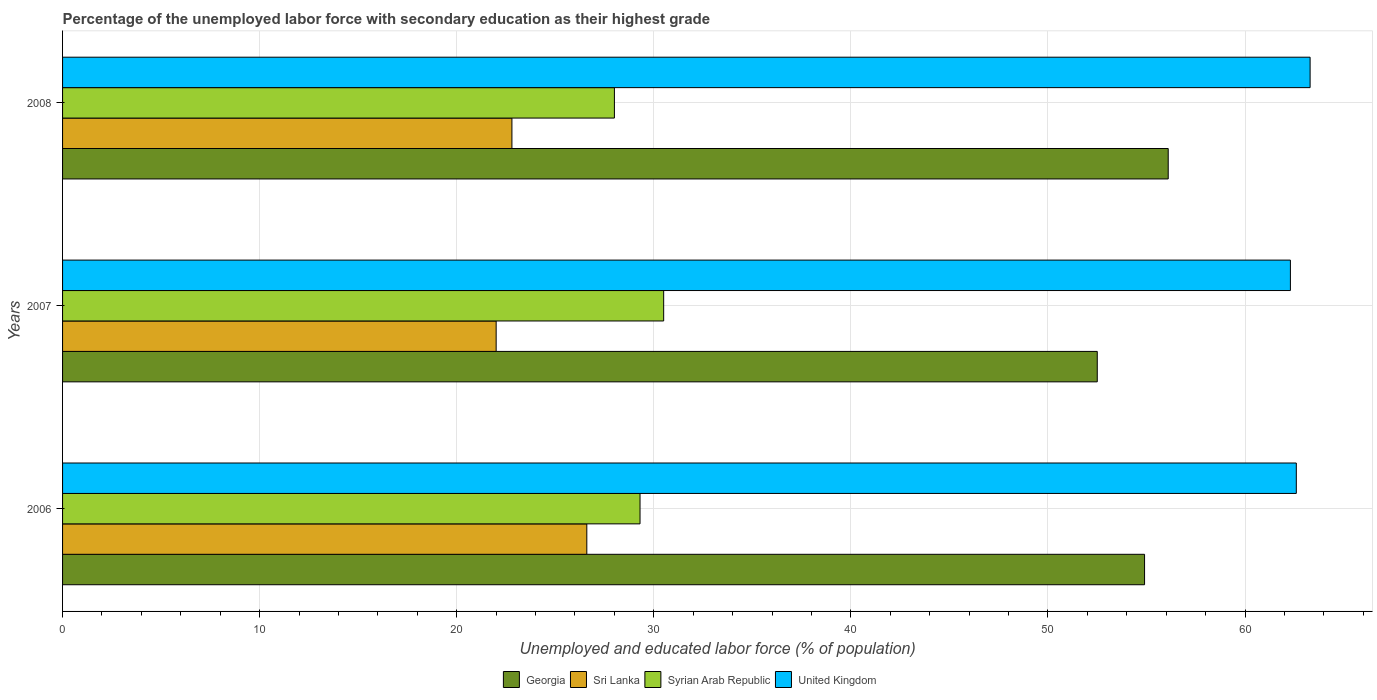How many different coloured bars are there?
Your response must be concise. 4. How many groups of bars are there?
Your response must be concise. 3. How many bars are there on the 1st tick from the bottom?
Your response must be concise. 4. What is the label of the 2nd group of bars from the top?
Your response must be concise. 2007. What is the percentage of the unemployed labor force with secondary education in Georgia in 2006?
Your response must be concise. 54.9. Across all years, what is the maximum percentage of the unemployed labor force with secondary education in Syrian Arab Republic?
Provide a succinct answer. 30.5. Across all years, what is the minimum percentage of the unemployed labor force with secondary education in United Kingdom?
Provide a succinct answer. 62.3. In which year was the percentage of the unemployed labor force with secondary education in Sri Lanka minimum?
Provide a short and direct response. 2007. What is the total percentage of the unemployed labor force with secondary education in United Kingdom in the graph?
Keep it short and to the point. 188.2. What is the difference between the percentage of the unemployed labor force with secondary education in United Kingdom in 2006 and that in 2008?
Your response must be concise. -0.7. What is the difference between the percentage of the unemployed labor force with secondary education in United Kingdom in 2006 and the percentage of the unemployed labor force with secondary education in Georgia in 2007?
Ensure brevity in your answer.  10.1. What is the average percentage of the unemployed labor force with secondary education in Georgia per year?
Your response must be concise. 54.5. In the year 2007, what is the difference between the percentage of the unemployed labor force with secondary education in Sri Lanka and percentage of the unemployed labor force with secondary education in Syrian Arab Republic?
Ensure brevity in your answer.  -8.5. In how many years, is the percentage of the unemployed labor force with secondary education in Syrian Arab Republic greater than 32 %?
Keep it short and to the point. 0. What is the ratio of the percentage of the unemployed labor force with secondary education in Georgia in 2006 to that in 2008?
Offer a very short reply. 0.98. Is the difference between the percentage of the unemployed labor force with secondary education in Sri Lanka in 2007 and 2008 greater than the difference between the percentage of the unemployed labor force with secondary education in Syrian Arab Republic in 2007 and 2008?
Your answer should be compact. No. What is the difference between the highest and the second highest percentage of the unemployed labor force with secondary education in United Kingdom?
Provide a succinct answer. 0.7. In how many years, is the percentage of the unemployed labor force with secondary education in Syrian Arab Republic greater than the average percentage of the unemployed labor force with secondary education in Syrian Arab Republic taken over all years?
Ensure brevity in your answer.  2. Is the sum of the percentage of the unemployed labor force with secondary education in Syrian Arab Republic in 2006 and 2007 greater than the maximum percentage of the unemployed labor force with secondary education in Sri Lanka across all years?
Your response must be concise. Yes. What does the 2nd bar from the top in 2006 represents?
Make the answer very short. Syrian Arab Republic. What does the 2nd bar from the bottom in 2006 represents?
Give a very brief answer. Sri Lanka. Is it the case that in every year, the sum of the percentage of the unemployed labor force with secondary education in United Kingdom and percentage of the unemployed labor force with secondary education in Sri Lanka is greater than the percentage of the unemployed labor force with secondary education in Georgia?
Make the answer very short. Yes. Are all the bars in the graph horizontal?
Ensure brevity in your answer.  Yes. What is the difference between two consecutive major ticks on the X-axis?
Keep it short and to the point. 10. Are the values on the major ticks of X-axis written in scientific E-notation?
Make the answer very short. No. Does the graph contain any zero values?
Your answer should be compact. No. Does the graph contain grids?
Your response must be concise. Yes. Where does the legend appear in the graph?
Provide a succinct answer. Bottom center. How are the legend labels stacked?
Your response must be concise. Horizontal. What is the title of the graph?
Keep it short and to the point. Percentage of the unemployed labor force with secondary education as their highest grade. Does "Guam" appear as one of the legend labels in the graph?
Your answer should be compact. No. What is the label or title of the X-axis?
Offer a very short reply. Unemployed and educated labor force (% of population). What is the Unemployed and educated labor force (% of population) in Georgia in 2006?
Make the answer very short. 54.9. What is the Unemployed and educated labor force (% of population) of Sri Lanka in 2006?
Ensure brevity in your answer.  26.6. What is the Unemployed and educated labor force (% of population) in Syrian Arab Republic in 2006?
Give a very brief answer. 29.3. What is the Unemployed and educated labor force (% of population) of United Kingdom in 2006?
Offer a terse response. 62.6. What is the Unemployed and educated labor force (% of population) in Georgia in 2007?
Your answer should be very brief. 52.5. What is the Unemployed and educated labor force (% of population) of Sri Lanka in 2007?
Provide a succinct answer. 22. What is the Unemployed and educated labor force (% of population) in Syrian Arab Republic in 2007?
Make the answer very short. 30.5. What is the Unemployed and educated labor force (% of population) in United Kingdom in 2007?
Your answer should be very brief. 62.3. What is the Unemployed and educated labor force (% of population) of Georgia in 2008?
Provide a succinct answer. 56.1. What is the Unemployed and educated labor force (% of population) of Sri Lanka in 2008?
Give a very brief answer. 22.8. What is the Unemployed and educated labor force (% of population) in United Kingdom in 2008?
Your answer should be very brief. 63.3. Across all years, what is the maximum Unemployed and educated labor force (% of population) of Georgia?
Keep it short and to the point. 56.1. Across all years, what is the maximum Unemployed and educated labor force (% of population) of Sri Lanka?
Ensure brevity in your answer.  26.6. Across all years, what is the maximum Unemployed and educated labor force (% of population) in Syrian Arab Republic?
Keep it short and to the point. 30.5. Across all years, what is the maximum Unemployed and educated labor force (% of population) in United Kingdom?
Your answer should be very brief. 63.3. Across all years, what is the minimum Unemployed and educated labor force (% of population) in Georgia?
Provide a short and direct response. 52.5. Across all years, what is the minimum Unemployed and educated labor force (% of population) of Sri Lanka?
Your answer should be very brief. 22. Across all years, what is the minimum Unemployed and educated labor force (% of population) in Syrian Arab Republic?
Your answer should be very brief. 28. Across all years, what is the minimum Unemployed and educated labor force (% of population) in United Kingdom?
Ensure brevity in your answer.  62.3. What is the total Unemployed and educated labor force (% of population) in Georgia in the graph?
Keep it short and to the point. 163.5. What is the total Unemployed and educated labor force (% of population) in Sri Lanka in the graph?
Keep it short and to the point. 71.4. What is the total Unemployed and educated labor force (% of population) of Syrian Arab Republic in the graph?
Your answer should be compact. 87.8. What is the total Unemployed and educated labor force (% of population) of United Kingdom in the graph?
Your response must be concise. 188.2. What is the difference between the Unemployed and educated labor force (% of population) of Georgia in 2006 and that in 2007?
Provide a succinct answer. 2.4. What is the difference between the Unemployed and educated labor force (% of population) of Sri Lanka in 2006 and that in 2007?
Ensure brevity in your answer.  4.6. What is the difference between the Unemployed and educated labor force (% of population) of Syrian Arab Republic in 2006 and that in 2007?
Make the answer very short. -1.2. What is the difference between the Unemployed and educated labor force (% of population) of United Kingdom in 2006 and that in 2007?
Keep it short and to the point. 0.3. What is the difference between the Unemployed and educated labor force (% of population) of Georgia in 2006 and that in 2008?
Offer a terse response. -1.2. What is the difference between the Unemployed and educated labor force (% of population) in Syrian Arab Republic in 2006 and that in 2008?
Your answer should be compact. 1.3. What is the difference between the Unemployed and educated labor force (% of population) of Georgia in 2007 and that in 2008?
Your answer should be compact. -3.6. What is the difference between the Unemployed and educated labor force (% of population) in United Kingdom in 2007 and that in 2008?
Provide a short and direct response. -1. What is the difference between the Unemployed and educated labor force (% of population) of Georgia in 2006 and the Unemployed and educated labor force (% of population) of Sri Lanka in 2007?
Ensure brevity in your answer.  32.9. What is the difference between the Unemployed and educated labor force (% of population) of Georgia in 2006 and the Unemployed and educated labor force (% of population) of Syrian Arab Republic in 2007?
Keep it short and to the point. 24.4. What is the difference between the Unemployed and educated labor force (% of population) of Sri Lanka in 2006 and the Unemployed and educated labor force (% of population) of United Kingdom in 2007?
Offer a terse response. -35.7. What is the difference between the Unemployed and educated labor force (% of population) in Syrian Arab Republic in 2006 and the Unemployed and educated labor force (% of population) in United Kingdom in 2007?
Provide a succinct answer. -33. What is the difference between the Unemployed and educated labor force (% of population) of Georgia in 2006 and the Unemployed and educated labor force (% of population) of Sri Lanka in 2008?
Offer a very short reply. 32.1. What is the difference between the Unemployed and educated labor force (% of population) of Georgia in 2006 and the Unemployed and educated labor force (% of population) of Syrian Arab Republic in 2008?
Your answer should be compact. 26.9. What is the difference between the Unemployed and educated labor force (% of population) in Sri Lanka in 2006 and the Unemployed and educated labor force (% of population) in United Kingdom in 2008?
Your answer should be compact. -36.7. What is the difference between the Unemployed and educated labor force (% of population) in Syrian Arab Republic in 2006 and the Unemployed and educated labor force (% of population) in United Kingdom in 2008?
Offer a very short reply. -34. What is the difference between the Unemployed and educated labor force (% of population) in Georgia in 2007 and the Unemployed and educated labor force (% of population) in Sri Lanka in 2008?
Your response must be concise. 29.7. What is the difference between the Unemployed and educated labor force (% of population) of Georgia in 2007 and the Unemployed and educated labor force (% of population) of United Kingdom in 2008?
Make the answer very short. -10.8. What is the difference between the Unemployed and educated labor force (% of population) in Sri Lanka in 2007 and the Unemployed and educated labor force (% of population) in United Kingdom in 2008?
Your answer should be very brief. -41.3. What is the difference between the Unemployed and educated labor force (% of population) in Syrian Arab Republic in 2007 and the Unemployed and educated labor force (% of population) in United Kingdom in 2008?
Make the answer very short. -32.8. What is the average Unemployed and educated labor force (% of population) in Georgia per year?
Ensure brevity in your answer.  54.5. What is the average Unemployed and educated labor force (% of population) of Sri Lanka per year?
Make the answer very short. 23.8. What is the average Unemployed and educated labor force (% of population) of Syrian Arab Republic per year?
Keep it short and to the point. 29.27. What is the average Unemployed and educated labor force (% of population) of United Kingdom per year?
Ensure brevity in your answer.  62.73. In the year 2006, what is the difference between the Unemployed and educated labor force (% of population) of Georgia and Unemployed and educated labor force (% of population) of Sri Lanka?
Your response must be concise. 28.3. In the year 2006, what is the difference between the Unemployed and educated labor force (% of population) in Georgia and Unemployed and educated labor force (% of population) in Syrian Arab Republic?
Your response must be concise. 25.6. In the year 2006, what is the difference between the Unemployed and educated labor force (% of population) in Georgia and Unemployed and educated labor force (% of population) in United Kingdom?
Make the answer very short. -7.7. In the year 2006, what is the difference between the Unemployed and educated labor force (% of population) in Sri Lanka and Unemployed and educated labor force (% of population) in United Kingdom?
Provide a short and direct response. -36. In the year 2006, what is the difference between the Unemployed and educated labor force (% of population) of Syrian Arab Republic and Unemployed and educated labor force (% of population) of United Kingdom?
Offer a terse response. -33.3. In the year 2007, what is the difference between the Unemployed and educated labor force (% of population) in Georgia and Unemployed and educated labor force (% of population) in Sri Lanka?
Make the answer very short. 30.5. In the year 2007, what is the difference between the Unemployed and educated labor force (% of population) of Sri Lanka and Unemployed and educated labor force (% of population) of United Kingdom?
Your answer should be compact. -40.3. In the year 2007, what is the difference between the Unemployed and educated labor force (% of population) in Syrian Arab Republic and Unemployed and educated labor force (% of population) in United Kingdom?
Offer a very short reply. -31.8. In the year 2008, what is the difference between the Unemployed and educated labor force (% of population) of Georgia and Unemployed and educated labor force (% of population) of Sri Lanka?
Keep it short and to the point. 33.3. In the year 2008, what is the difference between the Unemployed and educated labor force (% of population) of Georgia and Unemployed and educated labor force (% of population) of Syrian Arab Republic?
Your answer should be compact. 28.1. In the year 2008, what is the difference between the Unemployed and educated labor force (% of population) in Georgia and Unemployed and educated labor force (% of population) in United Kingdom?
Make the answer very short. -7.2. In the year 2008, what is the difference between the Unemployed and educated labor force (% of population) in Sri Lanka and Unemployed and educated labor force (% of population) in United Kingdom?
Make the answer very short. -40.5. In the year 2008, what is the difference between the Unemployed and educated labor force (% of population) in Syrian Arab Republic and Unemployed and educated labor force (% of population) in United Kingdom?
Your answer should be compact. -35.3. What is the ratio of the Unemployed and educated labor force (% of population) of Georgia in 2006 to that in 2007?
Ensure brevity in your answer.  1.05. What is the ratio of the Unemployed and educated labor force (% of population) in Sri Lanka in 2006 to that in 2007?
Keep it short and to the point. 1.21. What is the ratio of the Unemployed and educated labor force (% of population) of Syrian Arab Republic in 2006 to that in 2007?
Provide a short and direct response. 0.96. What is the ratio of the Unemployed and educated labor force (% of population) in Georgia in 2006 to that in 2008?
Offer a very short reply. 0.98. What is the ratio of the Unemployed and educated labor force (% of population) of Syrian Arab Republic in 2006 to that in 2008?
Make the answer very short. 1.05. What is the ratio of the Unemployed and educated labor force (% of population) in United Kingdom in 2006 to that in 2008?
Give a very brief answer. 0.99. What is the ratio of the Unemployed and educated labor force (% of population) in Georgia in 2007 to that in 2008?
Keep it short and to the point. 0.94. What is the ratio of the Unemployed and educated labor force (% of population) in Sri Lanka in 2007 to that in 2008?
Offer a very short reply. 0.96. What is the ratio of the Unemployed and educated labor force (% of population) in Syrian Arab Republic in 2007 to that in 2008?
Provide a short and direct response. 1.09. What is the ratio of the Unemployed and educated labor force (% of population) of United Kingdom in 2007 to that in 2008?
Provide a short and direct response. 0.98. What is the difference between the highest and the second highest Unemployed and educated labor force (% of population) in Syrian Arab Republic?
Make the answer very short. 1.2. 